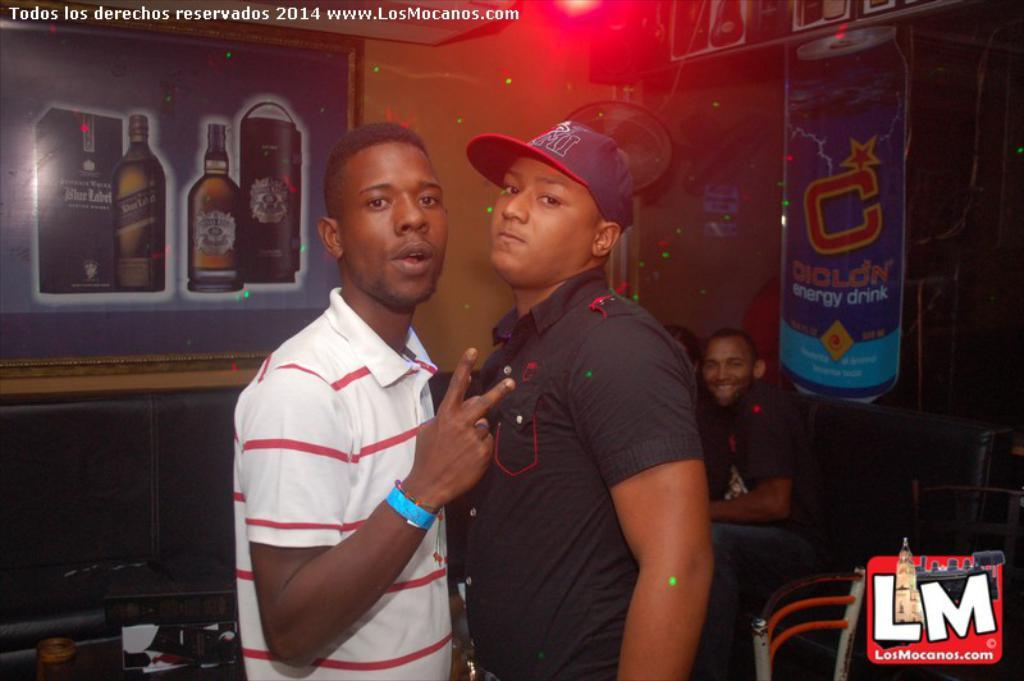How many people are visible in the image? There are two people in the image. Can you describe the background of the image? There are people, a wall, and objects in the background of the image. Is there any text present in the image? Yes, there is text in the top left corner of the image. What is located in the bottom right corner of the image? There is a logo in the bottom right corner of the image. What type of grape is being used as a sheet in the image? There is no grape or sheet present in the image. What type of art can be seen in the image? The image does not depict any specific art; it features two people, a background with people, a wall, and objects, and text and a logo in the corners. 